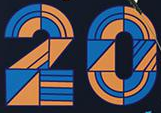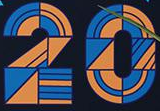What words can you see in these images in sequence, separated by a semicolon? 20; 20 